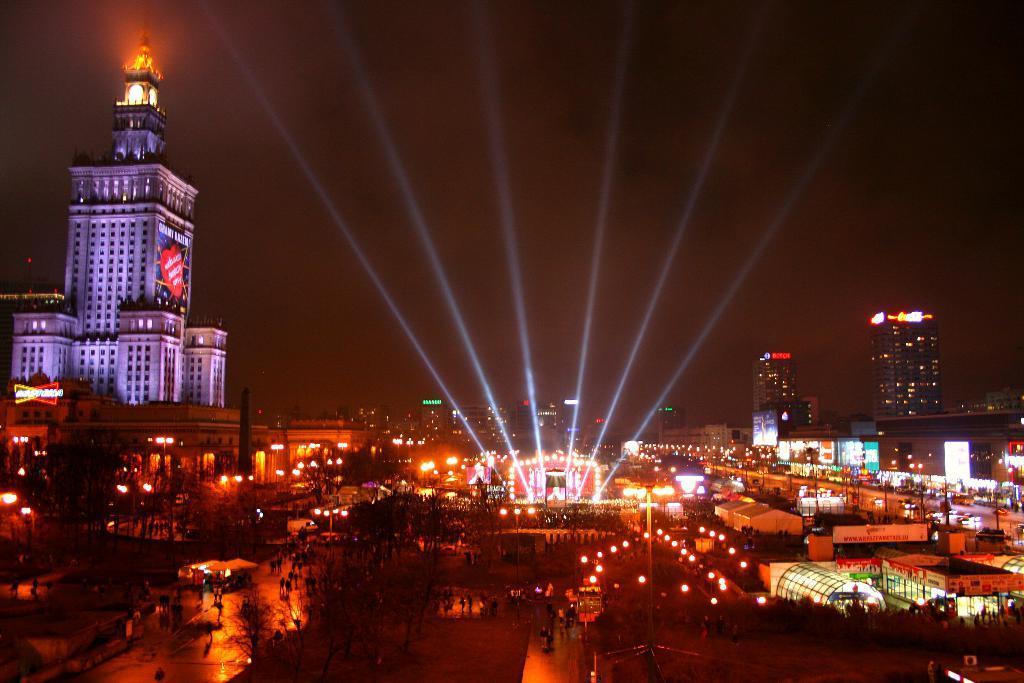Could you give a brief overview of what you see in this image? This picture is clicked outside. In the foreground we can see the group of people and we can see the lights, buildings, trees, skyscrapers, sky and many other objects. 